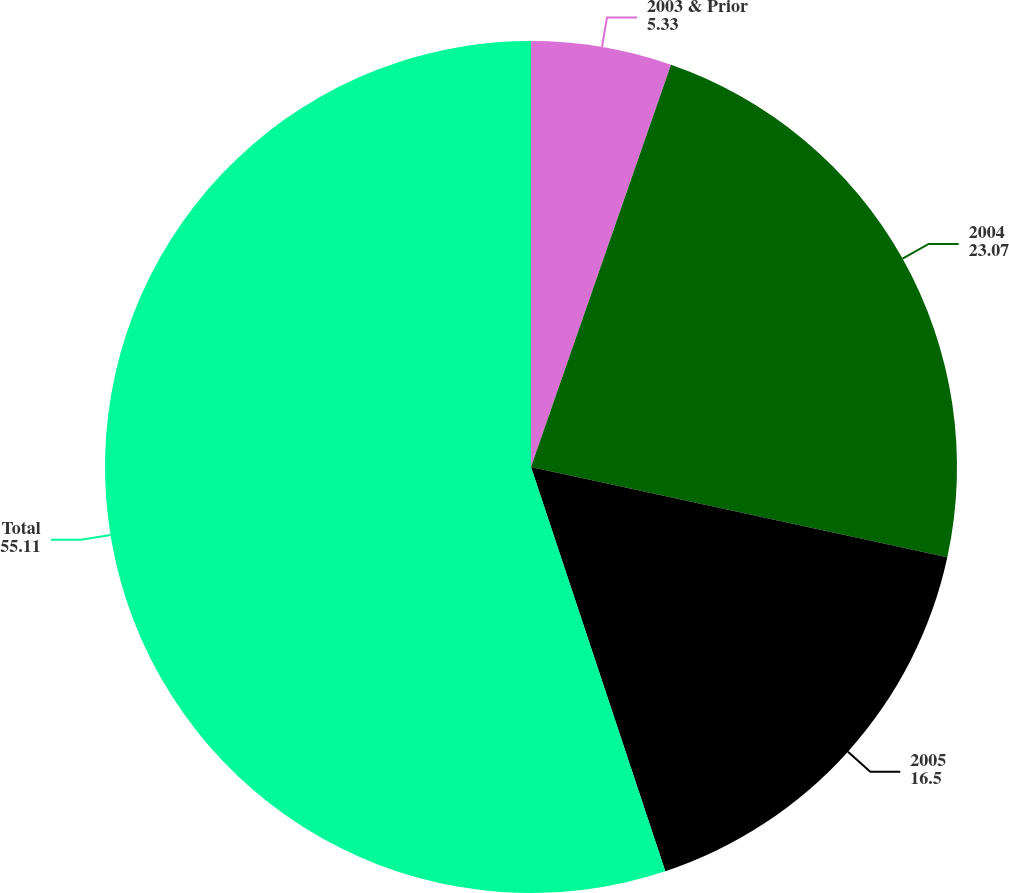Convert chart to OTSL. <chart><loc_0><loc_0><loc_500><loc_500><pie_chart><fcel>2003 & Prior<fcel>2004<fcel>2005<fcel>Total<nl><fcel>5.33%<fcel>23.07%<fcel>16.5%<fcel>55.11%<nl></chart> 